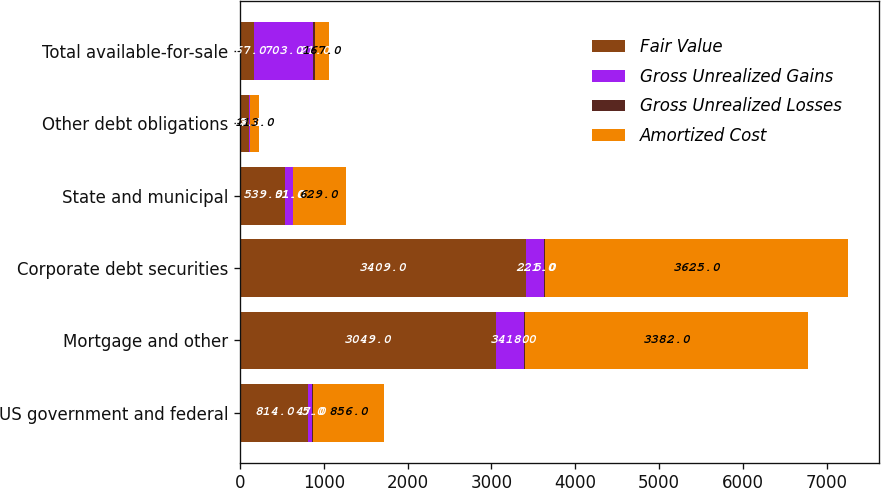<chart> <loc_0><loc_0><loc_500><loc_500><stacked_bar_chart><ecel><fcel>US government and federal<fcel>Mortgage and other<fcel>Corporate debt securities<fcel>State and municipal<fcel>Other debt obligations<fcel>Total available-for-sale<nl><fcel>Fair Value<fcel>814<fcel>3049<fcel>3409<fcel>539<fcel>112<fcel>167<nl><fcel>Gross Unrealized Gains<fcel>47<fcel>341<fcel>221<fcel>91<fcel>3<fcel>703<nl><fcel>Gross Unrealized Losses<fcel>5<fcel>8<fcel>5<fcel>1<fcel>2<fcel>21<nl><fcel>Amortized Cost<fcel>856<fcel>3382<fcel>3625<fcel>629<fcel>113<fcel>167<nl></chart> 